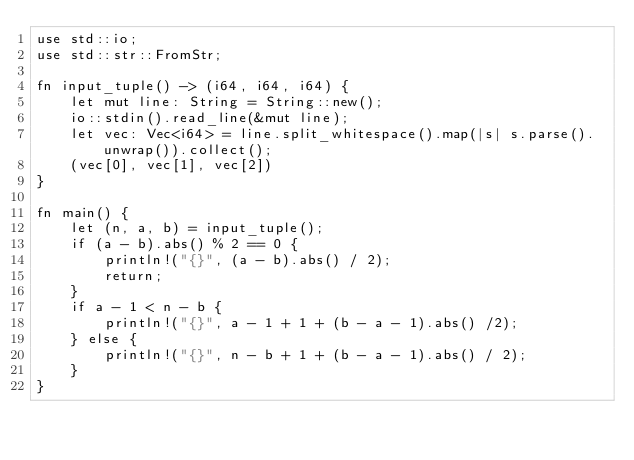Convert code to text. <code><loc_0><loc_0><loc_500><loc_500><_Rust_>use std::io;
use std::str::FromStr;

fn input_tuple() -> (i64, i64, i64) {
    let mut line: String = String::new();
    io::stdin().read_line(&mut line);
    let vec: Vec<i64> = line.split_whitespace().map(|s| s.parse().unwrap()).collect();
    (vec[0], vec[1], vec[2])
}

fn main() {
    let (n, a, b) = input_tuple();
    if (a - b).abs() % 2 == 0 {
        println!("{}", (a - b).abs() / 2);
        return;
    }
    if a - 1 < n - b {
        println!("{}", a - 1 + 1 + (b - a - 1).abs() /2);        
    } else {
        println!("{}", n - b + 1 + (b - a - 1).abs() / 2);
    }
}
</code> 